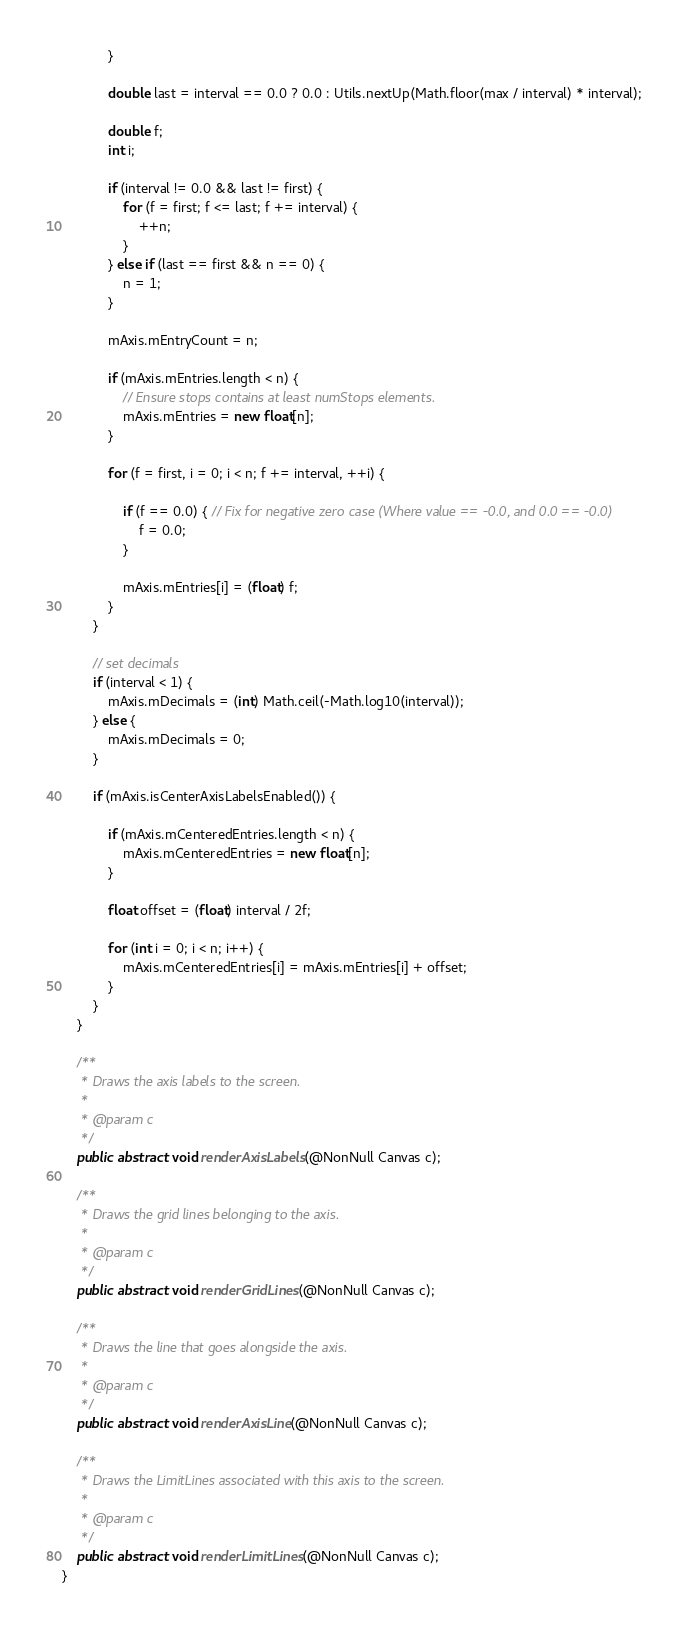<code> <loc_0><loc_0><loc_500><loc_500><_Java_>            }

            double last = interval == 0.0 ? 0.0 : Utils.nextUp(Math.floor(max / interval) * interval);

            double f;
            int i;

            if (interval != 0.0 && last != first) {
                for (f = first; f <= last; f += interval) {
                    ++n;
                }
            } else if (last == first && n == 0) {
                n = 1;
            }

            mAxis.mEntryCount = n;

            if (mAxis.mEntries.length < n) {
                // Ensure stops contains at least numStops elements.
                mAxis.mEntries = new float[n];
            }

            for (f = first, i = 0; i < n; f += interval, ++i) {

                if (f == 0.0) { // Fix for negative zero case (Where value == -0.0, and 0.0 == -0.0)
                    f = 0.0;
                }

                mAxis.mEntries[i] = (float) f;
            }
        }

        // set decimals
        if (interval < 1) {
            mAxis.mDecimals = (int) Math.ceil(-Math.log10(interval));
        } else {
            mAxis.mDecimals = 0;
        }

        if (mAxis.isCenterAxisLabelsEnabled()) {

            if (mAxis.mCenteredEntries.length < n) {
                mAxis.mCenteredEntries = new float[n];
            }

            float offset = (float) interval / 2f;

            for (int i = 0; i < n; i++) {
                mAxis.mCenteredEntries[i] = mAxis.mEntries[i] + offset;
            }
        }
    }

    /**
     * Draws the axis labels to the screen.
     *
     * @param c
     */
    public abstract void renderAxisLabels(@NonNull Canvas c);

    /**
     * Draws the grid lines belonging to the axis.
     *
     * @param c
     */
    public abstract void renderGridLines(@NonNull Canvas c);

    /**
     * Draws the line that goes alongside the axis.
     *
     * @param c
     */
    public abstract void renderAxisLine(@NonNull Canvas c);

    /**
     * Draws the LimitLines associated with this axis to the screen.
     *
     * @param c
     */
    public abstract void renderLimitLines(@NonNull Canvas c);
}
</code> 